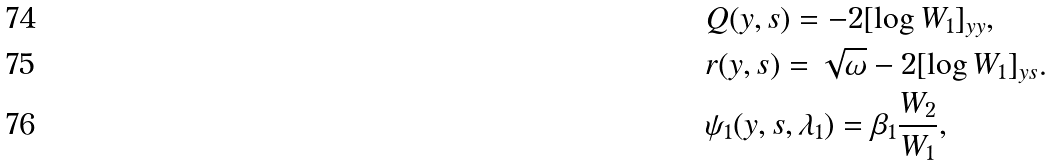Convert formula to latex. <formula><loc_0><loc_0><loc_500><loc_500>& Q ( y , s ) = - 2 [ \log W _ { 1 } ] _ { y y } , \\ & r ( y , s ) = \sqrt { \omega } - 2 [ \log W _ { 1 } ] _ { y s } . \\ & \psi _ { 1 } ( y , s , \lambda _ { 1 } ) = \beta _ { 1 } \frac { W _ { 2 } } { W _ { 1 } } ,</formula> 